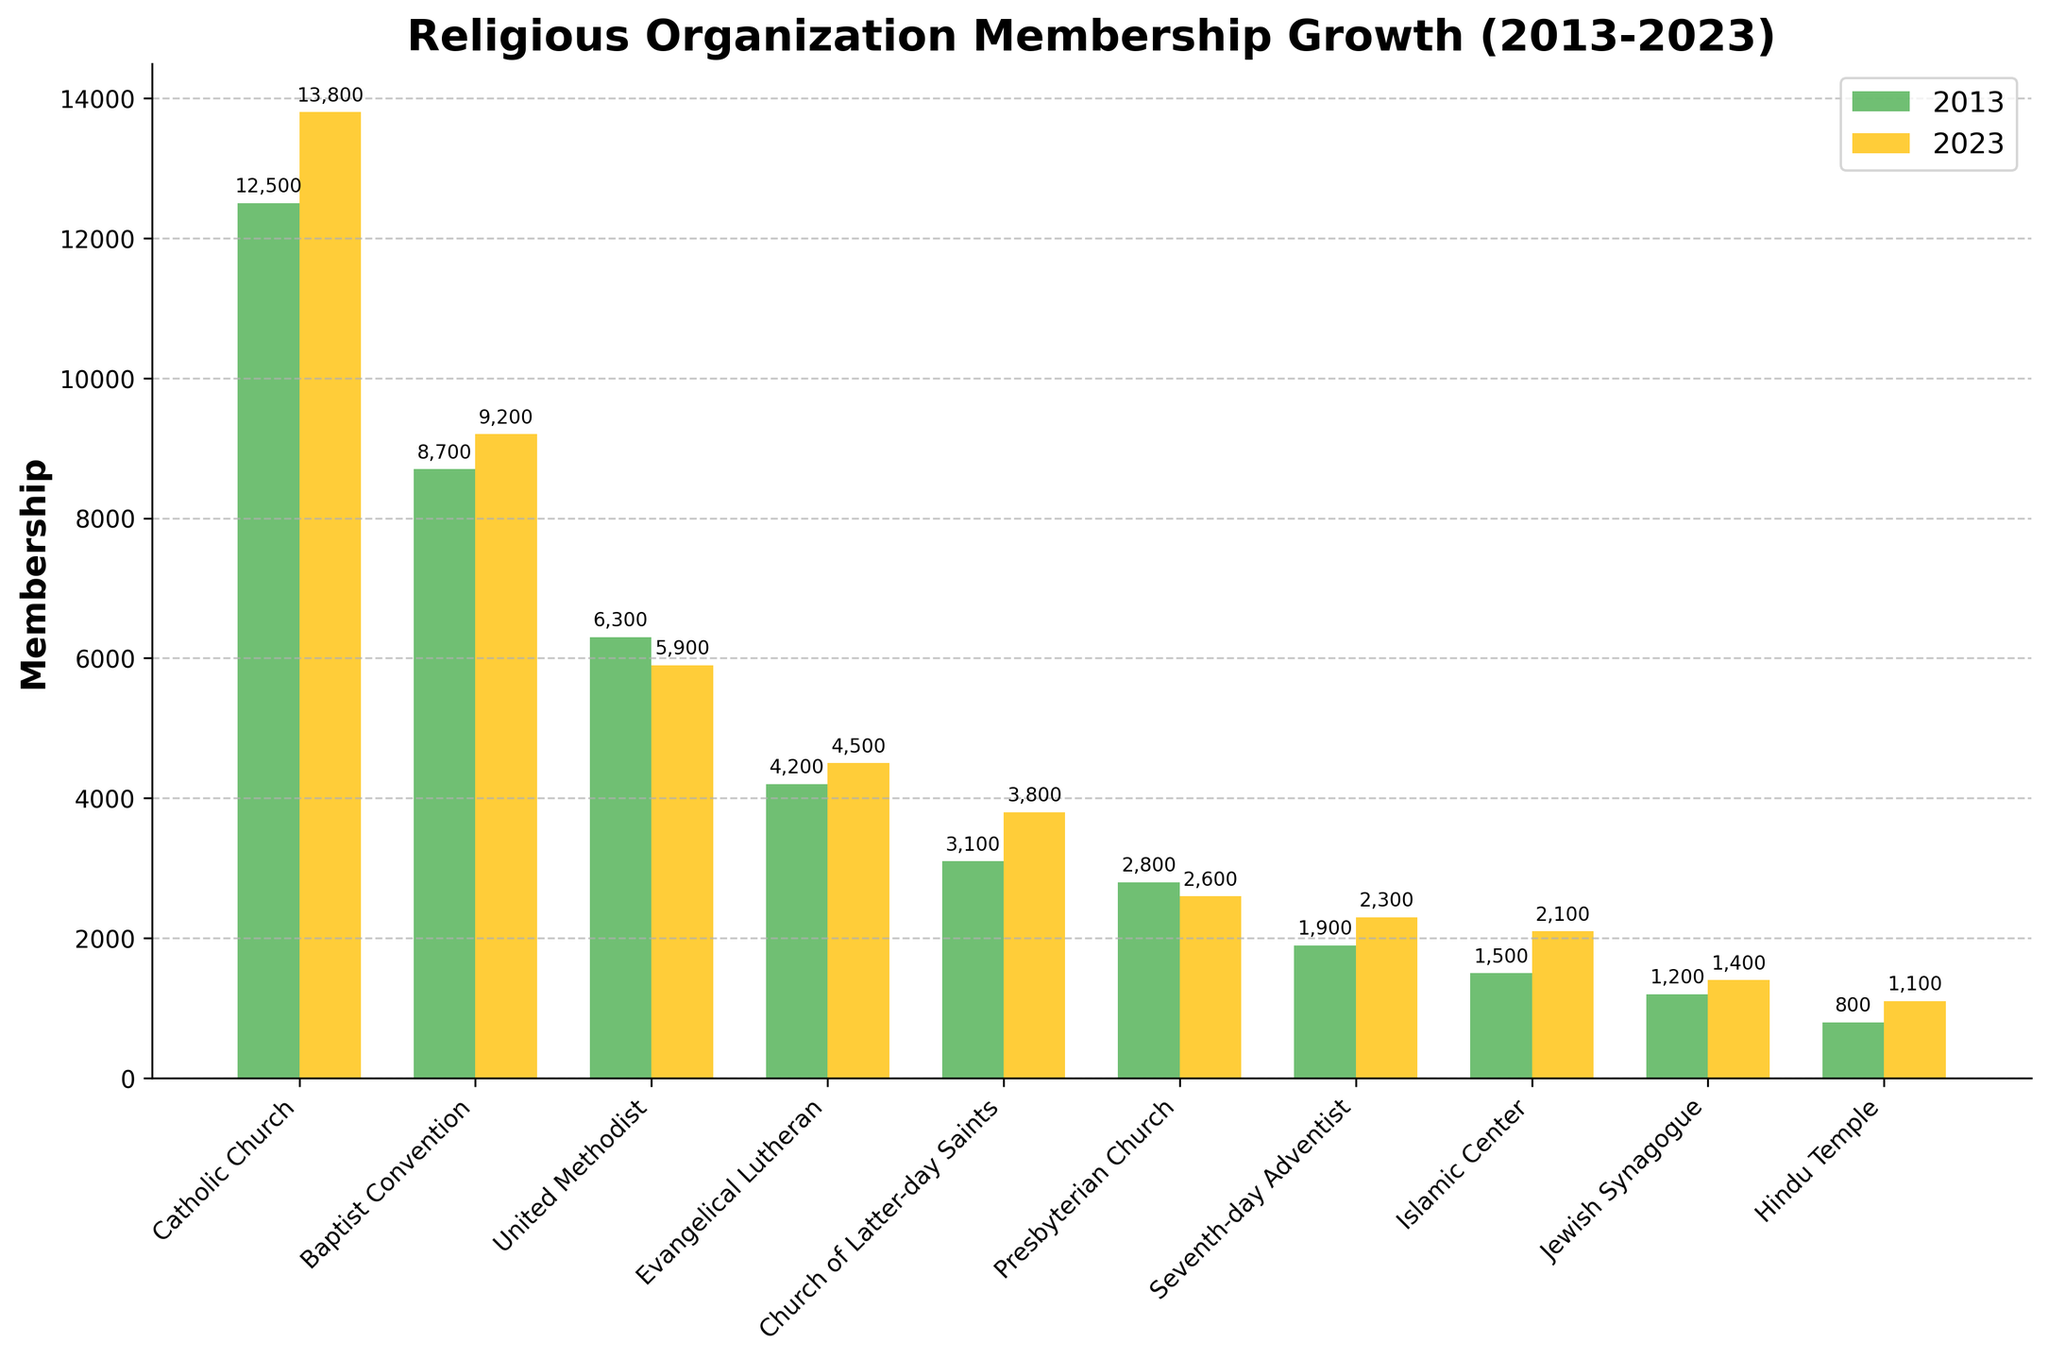What's the difference in membership between 2013 and 2023 for the Catholic Church? First, note the membership numbers for 2013 (12,500) and 2023 (13,800). Subtract the 2013 value from the 2023 value: 13,800 - 12,500 = 1,300.
Answer: 1,300 Which religious organization experienced a decrease in membership over the decade? Compare the membership values for 2013 and 2023 for each organization. The United Methodist (6,300 to 5,900) and the Presbyterian Church (2,800 to 2,600) show a decrease.
Answer: United Methodist, Presbyterian Church What is the total membership for all religious organizations in 2023? Sum the membership values for 2023: 13,800 + 9,200 + 5,900 + 4,500 + 3,800 + 2,600 + 2,300 + 2,100 + 1,400 + 1,100 = 46,700.
Answer: 46,700 Which organization has the highest membership growth in absolute numbers? Calculate the difference between 2023 and 2013 values for each religion, then find the maximum. Catholic Church has an increase of 13,800 - 12,500 = 1,300, which is the largest.
Answer: Catholic Church By how much did the membership of the Hindu Temple increase from 2013 to 2023? Subtract the 2013 membership value from the 2023 value: 1,100 - 800 = 300.
Answer: 300 What is the combined membership of the Islamic Center and Jewish Synagogue in 2023? Add the membership values for the Islamic Center (2,100) and Jewish Synagogue (1,400) for 2023: 2,100 + 1,400 = 3,500.
Answer: 3,500 Which religious organization has the smallest membership in 2023? Look at the values for all organizations in 2023. Hindu Temple has the smallest membership of 1,100.
Answer: Hindu Temple Which organizations had a membership below 5,000 in 2023? Identify all organizations with membership values lower than 5,000 in 2023: Evangelical Lutheran (4,500), Church of Latter-day Saints (3,800), Presbyterian Church (2,600), Seventh-day Adventist (2,300), Islamic Center (2,100), Jewish Synagogue (1,400), Hindu Temple (1,100).
Answer: Evangelical Lutheran, Church of Latter-day Saints, Presbyterian Church, Seventh-day Adventist, Islamic Center, Jewish Synagogue, Hindu Temple How much higher is the Baptist Convention's membership in 2023 compared to the United Methodist in 2023? Subtract the United Methodist's membership from the Baptist Convention's membership for 2023: 9,200 - 5,900 = 3,300.
Answer: 3,300 What is the average membership of religious organizations in 2013? Sum the memberships for 2013 (12,500 + 8,700 + 6,300 + 4,200 + 3,100 + 2,800 + 1,900 + 1,500 + 1,200 + 800 = 43,000) and divide by the number of organizations (10): 43,000 / 10 = 4,300.
Answer: 4,300 